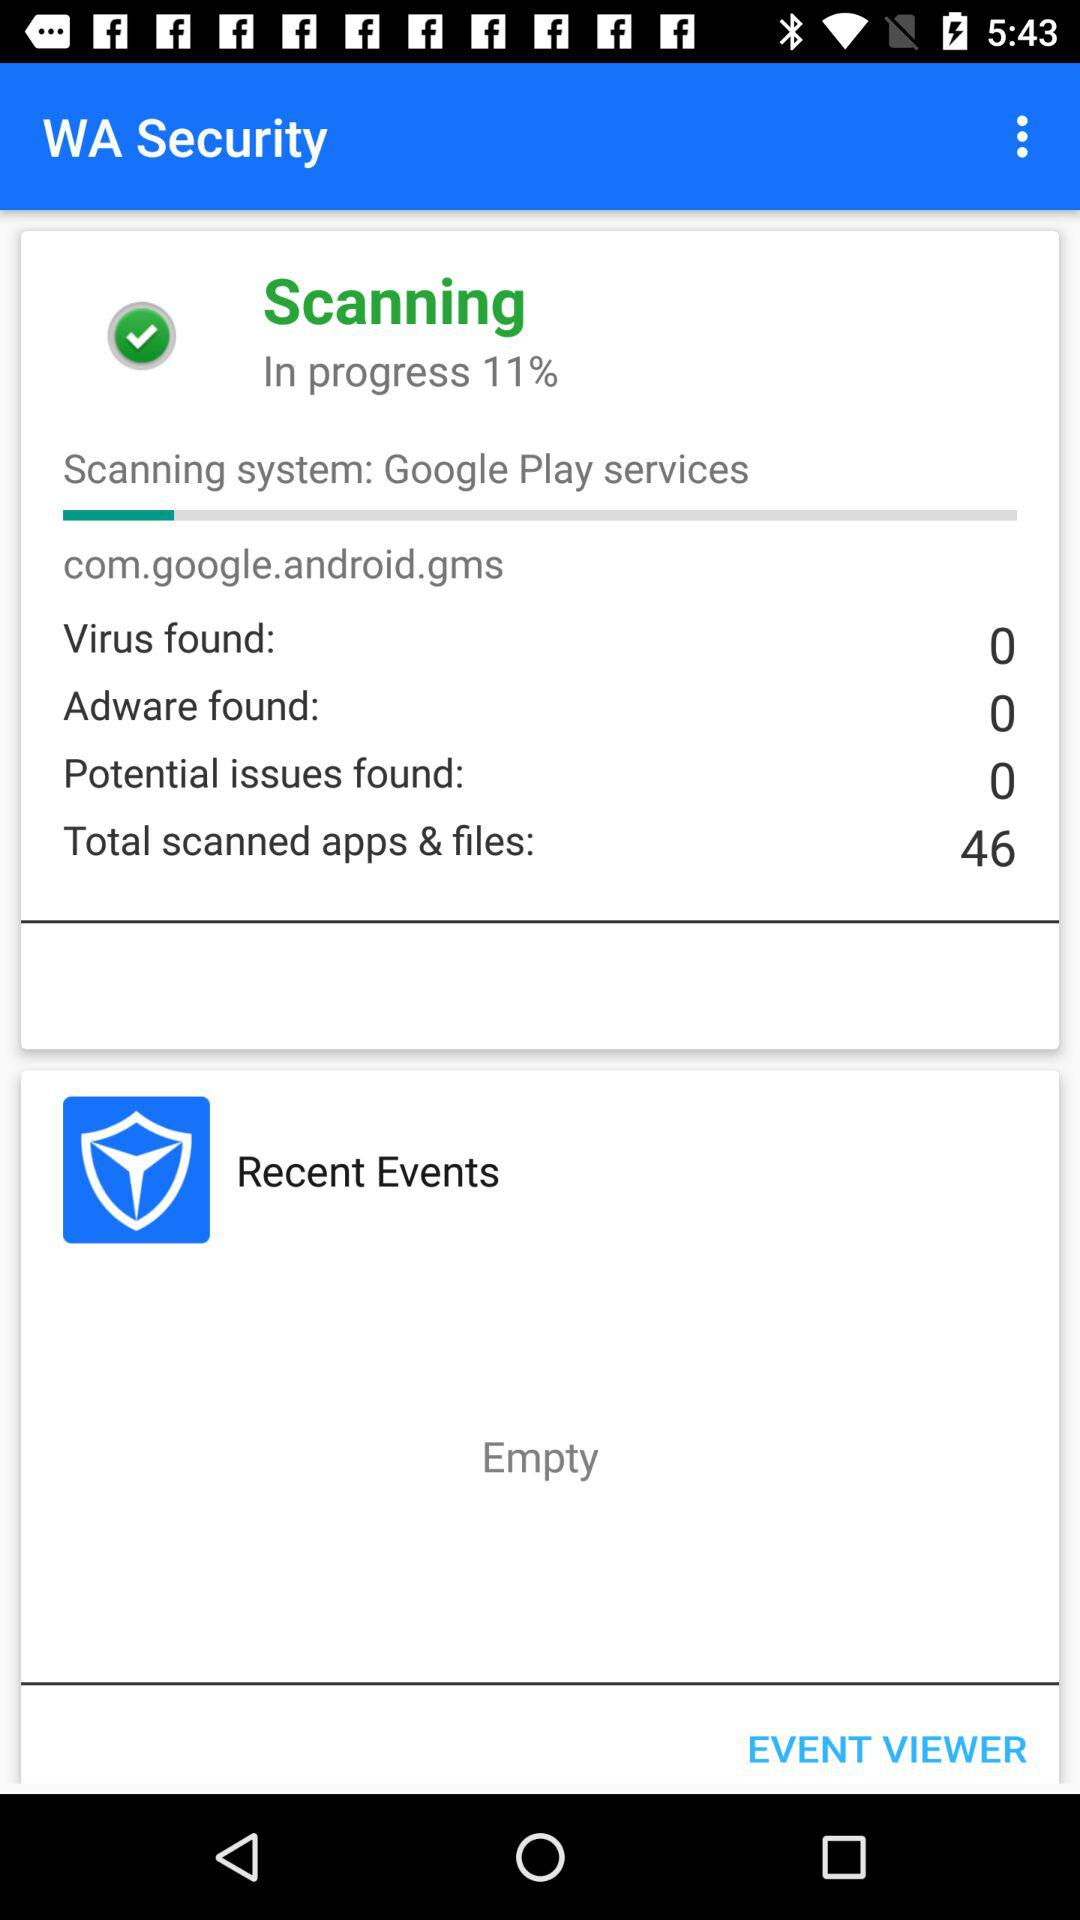How many more adwares than potential issues were found?
Answer the question using a single word or phrase. 0 